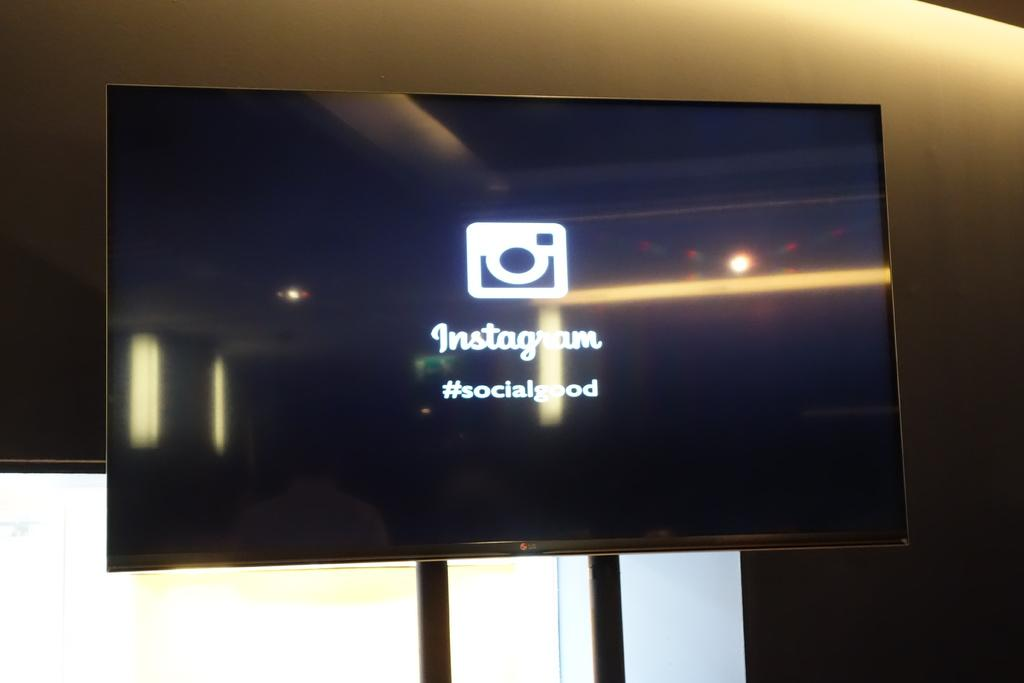<image>
Offer a succinct explanation of the picture presented. Black television screen with white instagram logo and #socialgood 